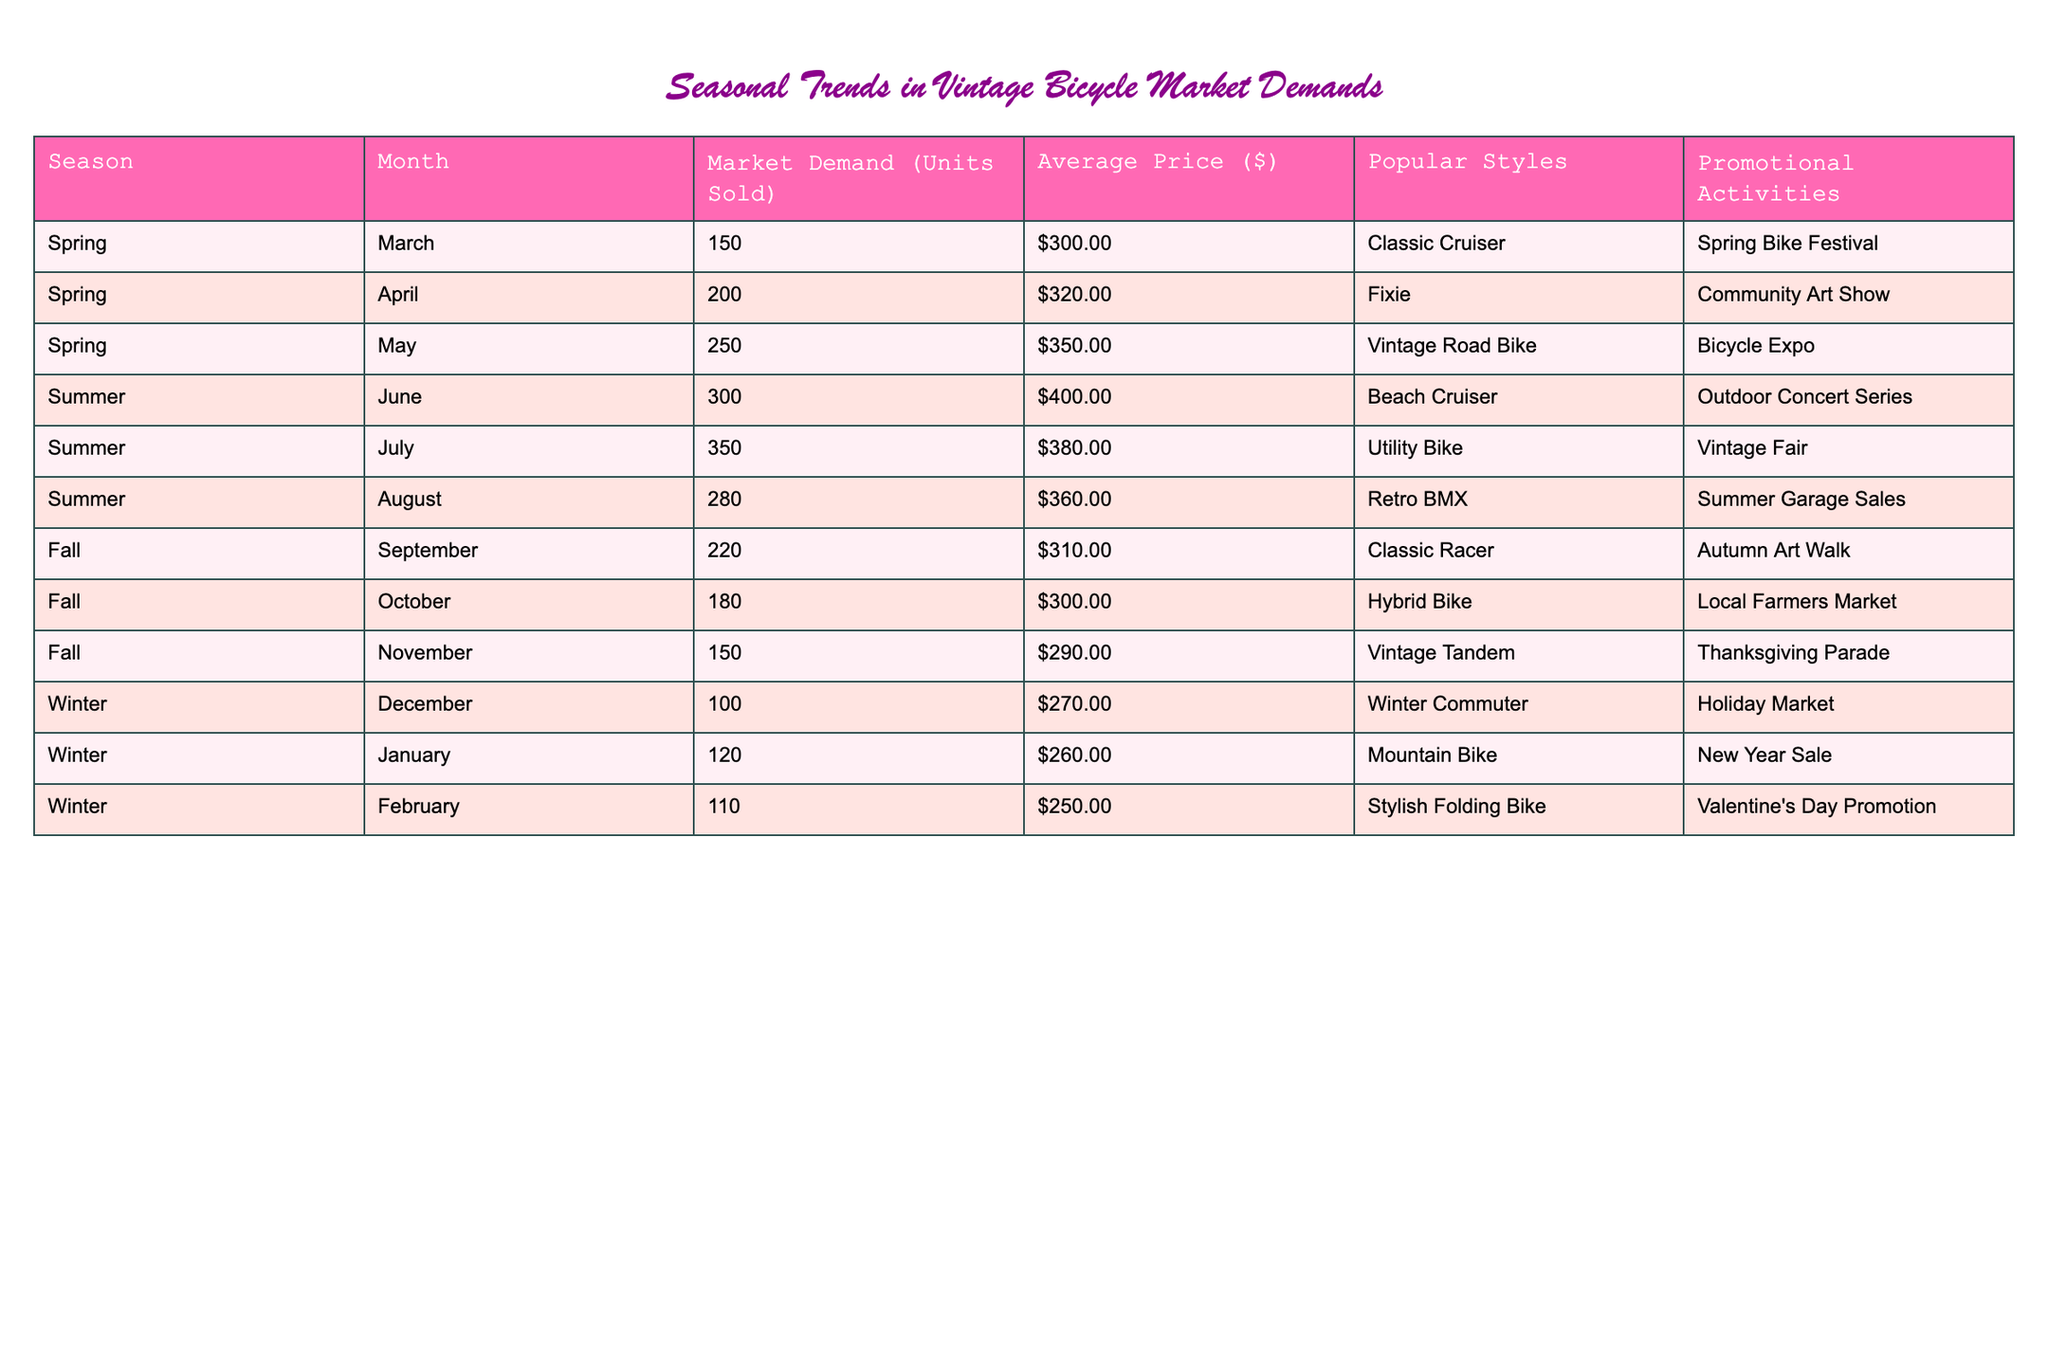What is the market demand for vintage bicycles in May? The table shows that for the month of May, the market demand is 250 units sold.
Answer: 250 Which month has the highest average price for vintage bicycles? By looking at the average prices across the months, June has the highest price at $400.00.
Answer: $400 How many units of vintage bicycles were sold during the summer months (June, July, August) combined? Adding the market demand for June (300), July (350), and August (280) gives a total of 300 + 350 + 280 = 930 units.
Answer: 930 Is there a promotional activity associated with the market demand in November? The table indicates that there is a promotional activity for November, which is the Thanksgiving Parade.
Answer: Yes What is the average market demand during the winter months (December, January, February)? The market demands for December (100), January (120), and February (110) sum up to 330. Dividing by the 3 months gives an average of 330 / 3 = 110.
Answer: 110 What style of vintage bicycle is the most popular in July, and how does its price compare to the average price in June? In July, the most popular style is the Utility Bike priced at $380. Comparing with June's price of $400, the Utility Bike is $20 cheaper.
Answer: $20 cheaper What is the change in market demand from March to September? The market demand for March is 150 units and for September is 220 units. The change is 220 - 150 = 70 units increase.
Answer: 70 units increase Which month has the lowest number of units sold, and how many were sold? December has the lowest number of units sold at 100.
Answer: 100 